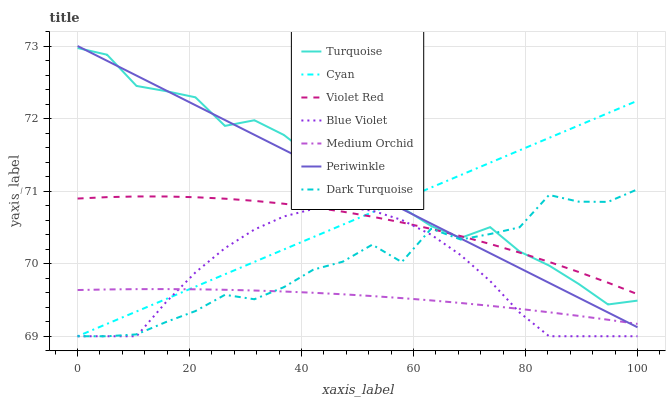Does Dark Turquoise have the minimum area under the curve?
Answer yes or no. No. Does Dark Turquoise have the maximum area under the curve?
Answer yes or no. No. Is Medium Orchid the smoothest?
Answer yes or no. No. Is Medium Orchid the roughest?
Answer yes or no. No. Does Medium Orchid have the lowest value?
Answer yes or no. No. Does Dark Turquoise have the highest value?
Answer yes or no. No. Is Blue Violet less than Periwinkle?
Answer yes or no. Yes. Is Periwinkle greater than Blue Violet?
Answer yes or no. Yes. Does Blue Violet intersect Periwinkle?
Answer yes or no. No. 